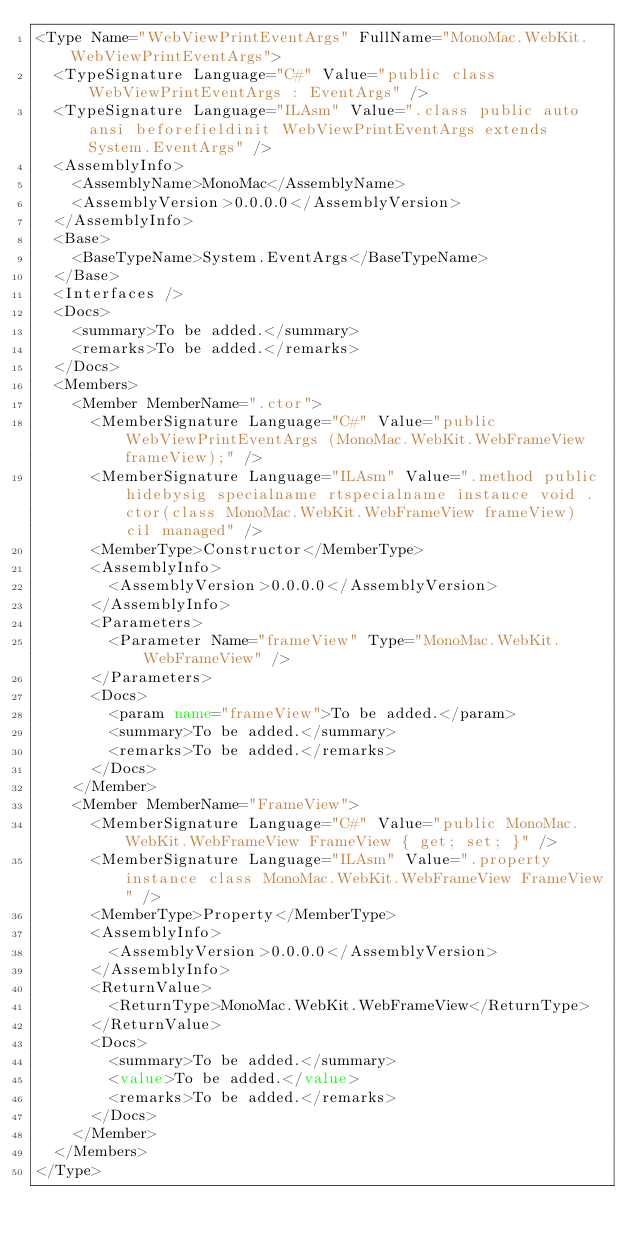<code> <loc_0><loc_0><loc_500><loc_500><_XML_><Type Name="WebViewPrintEventArgs" FullName="MonoMac.WebKit.WebViewPrintEventArgs">
  <TypeSignature Language="C#" Value="public class WebViewPrintEventArgs : EventArgs" />
  <TypeSignature Language="ILAsm" Value=".class public auto ansi beforefieldinit WebViewPrintEventArgs extends System.EventArgs" />
  <AssemblyInfo>
    <AssemblyName>MonoMac</AssemblyName>
    <AssemblyVersion>0.0.0.0</AssemblyVersion>
  </AssemblyInfo>
  <Base>
    <BaseTypeName>System.EventArgs</BaseTypeName>
  </Base>
  <Interfaces />
  <Docs>
    <summary>To be added.</summary>
    <remarks>To be added.</remarks>
  </Docs>
  <Members>
    <Member MemberName=".ctor">
      <MemberSignature Language="C#" Value="public WebViewPrintEventArgs (MonoMac.WebKit.WebFrameView frameView);" />
      <MemberSignature Language="ILAsm" Value=".method public hidebysig specialname rtspecialname instance void .ctor(class MonoMac.WebKit.WebFrameView frameView) cil managed" />
      <MemberType>Constructor</MemberType>
      <AssemblyInfo>
        <AssemblyVersion>0.0.0.0</AssemblyVersion>
      </AssemblyInfo>
      <Parameters>
        <Parameter Name="frameView" Type="MonoMac.WebKit.WebFrameView" />
      </Parameters>
      <Docs>
        <param name="frameView">To be added.</param>
        <summary>To be added.</summary>
        <remarks>To be added.</remarks>
      </Docs>
    </Member>
    <Member MemberName="FrameView">
      <MemberSignature Language="C#" Value="public MonoMac.WebKit.WebFrameView FrameView { get; set; }" />
      <MemberSignature Language="ILAsm" Value=".property instance class MonoMac.WebKit.WebFrameView FrameView" />
      <MemberType>Property</MemberType>
      <AssemblyInfo>
        <AssemblyVersion>0.0.0.0</AssemblyVersion>
      </AssemblyInfo>
      <ReturnValue>
        <ReturnType>MonoMac.WebKit.WebFrameView</ReturnType>
      </ReturnValue>
      <Docs>
        <summary>To be added.</summary>
        <value>To be added.</value>
        <remarks>To be added.</remarks>
      </Docs>
    </Member>
  </Members>
</Type>
</code> 